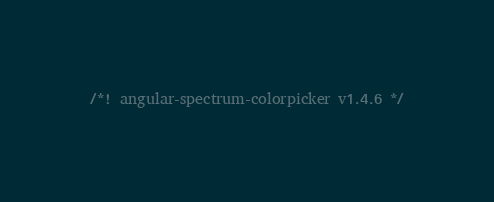Convert code to text. <code><loc_0><loc_0><loc_500><loc_500><_JavaScript_>/*! angular-spectrum-colorpicker v1.4.6 */</code> 